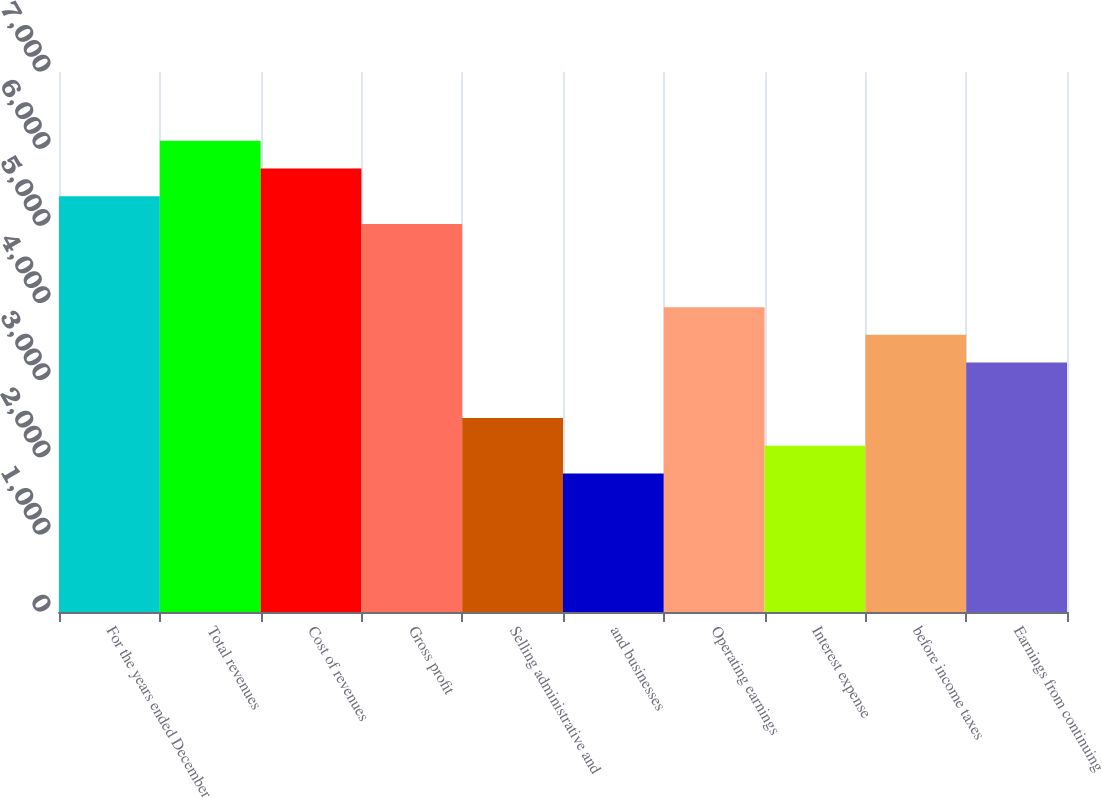<chart> <loc_0><loc_0><loc_500><loc_500><bar_chart><fcel>For the years ended December<fcel>Total revenues<fcel>Cost of revenues<fcel>Gross profit<fcel>Selling administrative and<fcel>and businesses<fcel>Operating earnings<fcel>Interest expense<fcel>before income taxes<fcel>Earnings from continuing<nl><fcel>5389.07<fcel>6107.61<fcel>5748.34<fcel>5029.8<fcel>2514.91<fcel>1796.37<fcel>3951.99<fcel>2155.64<fcel>3592.72<fcel>3233.45<nl></chart> 